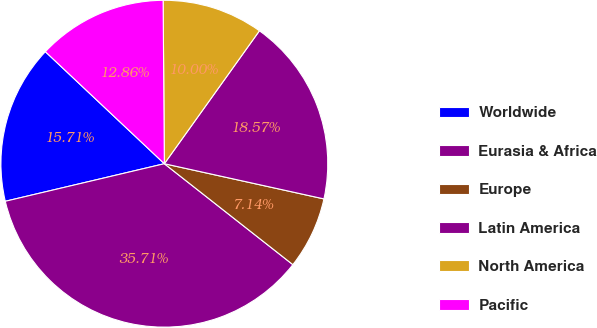Convert chart. <chart><loc_0><loc_0><loc_500><loc_500><pie_chart><fcel>Worldwide<fcel>Eurasia & Africa<fcel>Europe<fcel>Latin America<fcel>North America<fcel>Pacific<nl><fcel>15.71%<fcel>35.71%<fcel>7.14%<fcel>18.57%<fcel>10.0%<fcel>12.86%<nl></chart> 